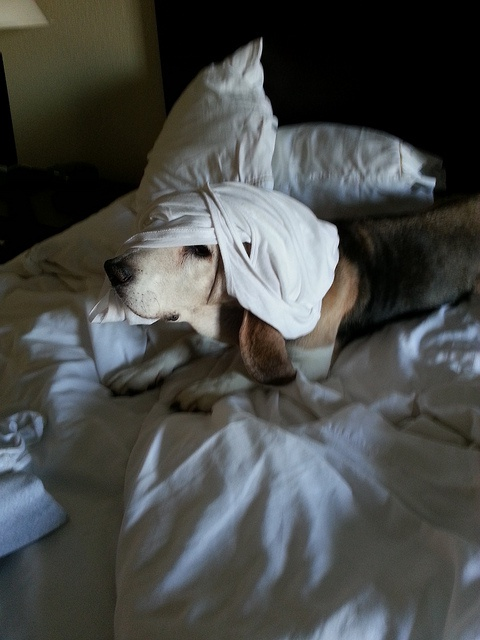Describe the objects in this image and their specific colors. I can see bed in gray, black, and darkgray tones and dog in gray, black, lightgray, and darkgray tones in this image. 